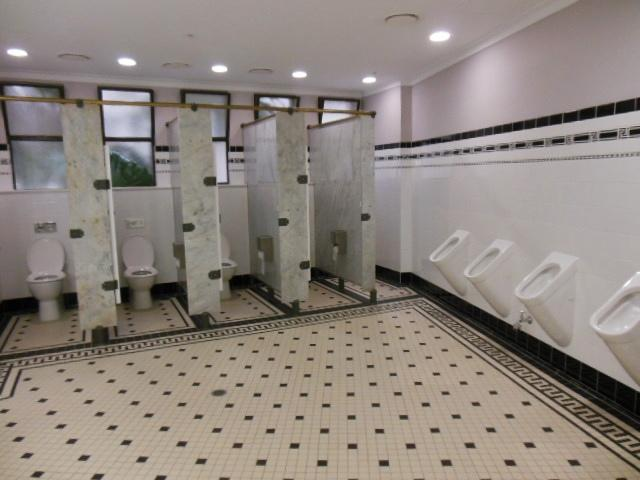What type of location is this? bathroom 